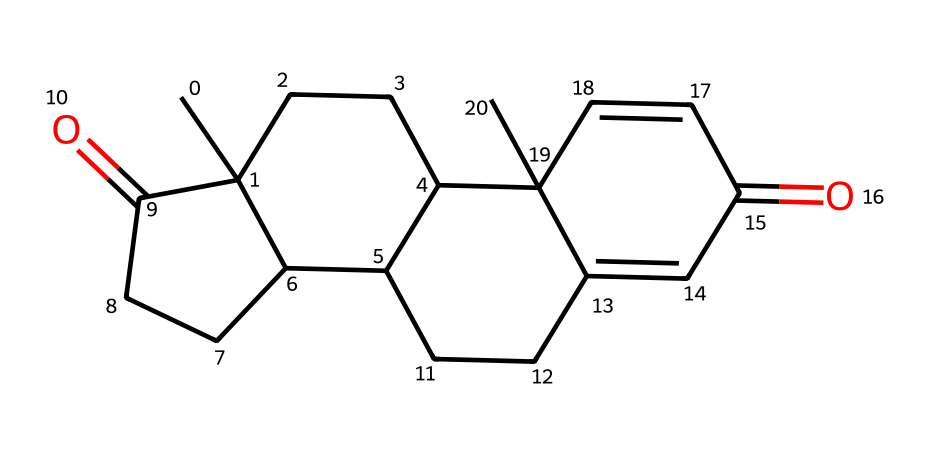What is the primary functional group present in 7-keto-DHEA? The structure shows a carbonyl group (C=O), which is characteristic of ketones. This can be identified by looking for the C=O bond in the structure.
Answer: ketone How many rings are present in the chemical structure of 7-keto-DHEA? By analyzing the structure, there are four distinct cyclic formations (rings) in the arrangement, which can be counted visually.
Answer: four What is the total number of carbon atoms in 7-keto-DHEA? Counting the carbon atoms in the SMILES representation provides a total number. The arrangement indicates 18 carbon atoms.
Answer: 18 What type of isomerism can occur in ketones like 7-keto-DHEA? Since ketones have a carbonyl group, they can exhibit structural isomerism due to different possible placements of the carbonyl in the carbon chain.
Answer: structural isomerism What molecular property is likely enhanced due to the presence of the carbonyl group in ketones? The carbonyl group's polarity gives rise to enhanced interactions such as hydrogen bonding, which often increases solubility in polar solvents.
Answer: solubility How does the presence of the keto group in 7-keto-DHEA relate to its metabolic function? The keto group can participate in metabolic processes as it can be involved in reactions that mobilize fat stores, highlighting its role in fat burning.
Answer: fat-burning 